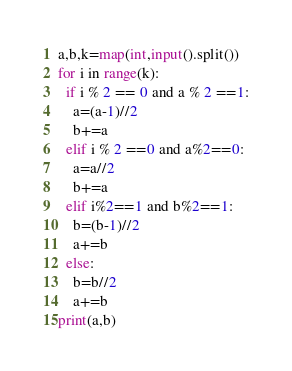<code> <loc_0><loc_0><loc_500><loc_500><_Python_>a,b,k=map(int,input().split())
for i in range(k):
  if i % 2 == 0 and a % 2 ==1:
    a=(a-1)//2
    b+=a
  elif i % 2 ==0 and a%2==0:
    a=a//2
    b+=a
  elif i%2==1 and b%2==1:
    b=(b-1)//2
    a+=b
  else:
    b=b//2
    a+=b
print(a,b)</code> 